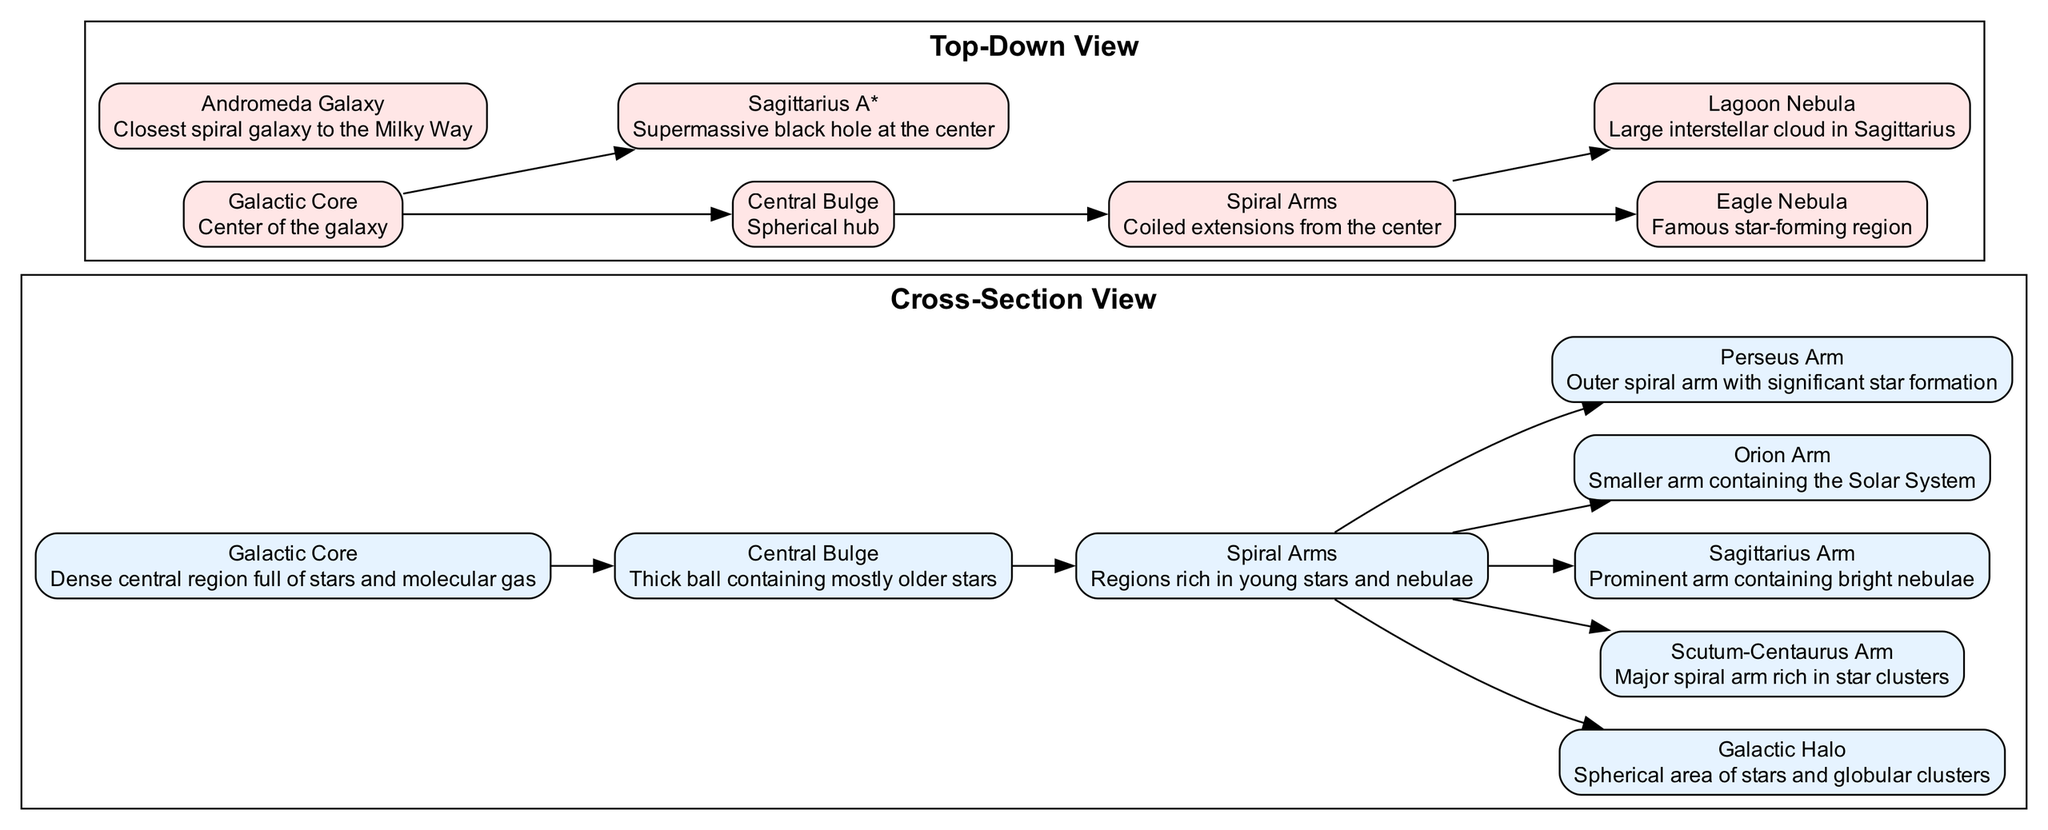What's the name of the central feature in the diagram? The central feature is indicated as the "Galactic Core," which represents the dense central region of the Milky Way galaxy.
Answer: Galactic Core How many major spiral arms are labeled in the diagram? The diagram labels four major spiral arms: Scutum-Centaurus Arm, Sagittarius Arm, Orion Arm, and Perseus Arm. This can be counted directly from the elements listed under the cross-sectional and top-down views.
Answer: 4 What is located directly below the Galactic Core in the top-down view? In the top-down view, "Sagittarius A*" is located directly below the Galactic Core, which represents the supermassive black hole at the center of the galaxy.
Answer: Sagittarius A* Which component connects to both the Galactic Core and the Central Bulge? The "Central Bulge" connects to both the "Galactic Core" and serves as a thick ball containing mostly older stars, depicting the structure of the galaxy’s core.
Answer: Central Bulge Which nebula is associated with star formation, as per the description? The "Eagle Nebula," described as a famous star-forming region, is explicitly indicated within the diagram as one of the nebulae present in the Milky Way.
Answer: Eagle Nebula Which arm contains the Solar System according to the diagram? The "Orion Arm" is specified as the smaller arm that contains the Solar System, indicating its location within the galactic structure.
Answer: Orion Arm What features are part of the Galactic Halo according to the diagram? The "Galactic Halo" is referred to in the context of the diagram as a spherical area consisting of stars and globular clusters, representing the outer limits of the galaxy.
Answer: Stars and globular clusters How would you describe the Central Bulge based on the diagram? The diagram describes the "Central Bulge" as a thick ball that contains mostly older stars, highlighting its composition relative to other features in the galaxy.
Answer: Thick ball containing mostly older stars What is the closest galaxy to the Milky Way depicted in the top-down view? The "Andromeda Galaxy" is indicated as the closest spiral galaxy to the Milky Way in the top-down view, directly representing its nearby galactic neighbor.
Answer: Andromeda Galaxy 